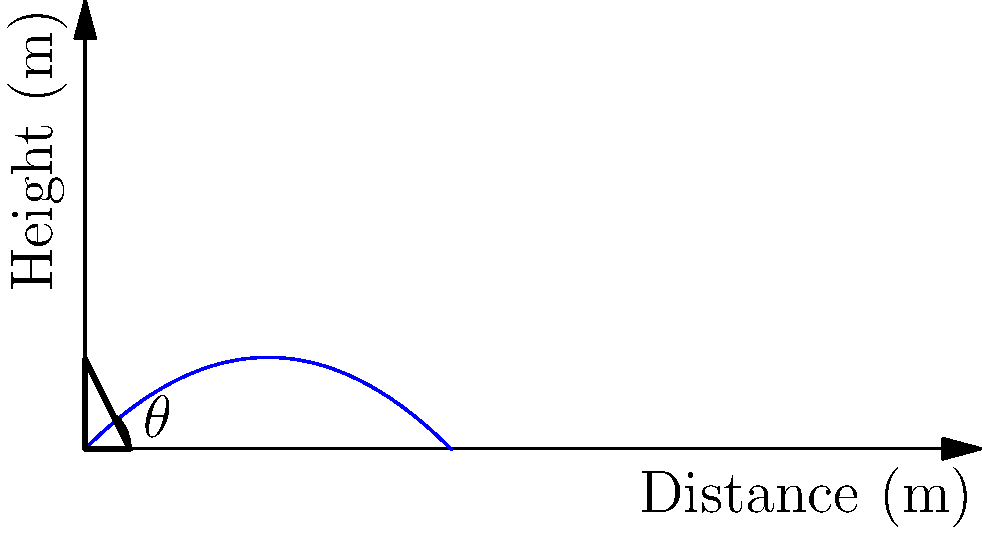As the owner of a toy store, you're designing a toy catapult for a community playdate event. The catapult launches a small foam ball with an initial velocity of 20 m/s. Assuming air resistance is negligible, at what angle $\theta$ should the catapult be set to achieve the maximum horizontal distance? Use $g = 9.8$ m/s² for acceleration due to gravity. To find the optimal angle for maximum distance, we can follow these steps:

1) The horizontal distance traveled by a projectile is given by:
   $$R = \frac{v_0^2 \sin(2\theta)}{g}$$
   where $R$ is the range, $v_0$ is the initial velocity, $\theta$ is the launch angle, and $g$ is the acceleration due to gravity.

2) To find the maximum distance, we need to find the angle that maximizes this function. We can do this by differentiating $R$ with respect to $\theta$ and setting it to zero:

   $$\frac{dR}{d\theta} = \frac{v_0^2}{g} \cdot 2\cos(2\theta) = 0$$

3) Solving this equation:
   $$2\cos(2\theta) = 0$$
   $$\cos(2\theta) = 0$$

4) The cosine function is zero when its argument is $\frac{\pi}{2}$ or $\frac{3\pi}{2}$. So:
   $$2\theta = \frac{\pi}{2}$$ or $$2\theta = \frac{3\pi}{2}$$

5) Solving for $\theta$:
   $$\theta = \frac{\pi}{4}$$ or $$\theta = \frac{3\pi}{4}$$

6) The angle $\frac{\pi}{4}$ (45°) gives the maximum range, while $\frac{3\pi}{4}$ (135°) gives the minimum.

Therefore, the optimal angle for maximum distance is 45°.
Answer: 45° 